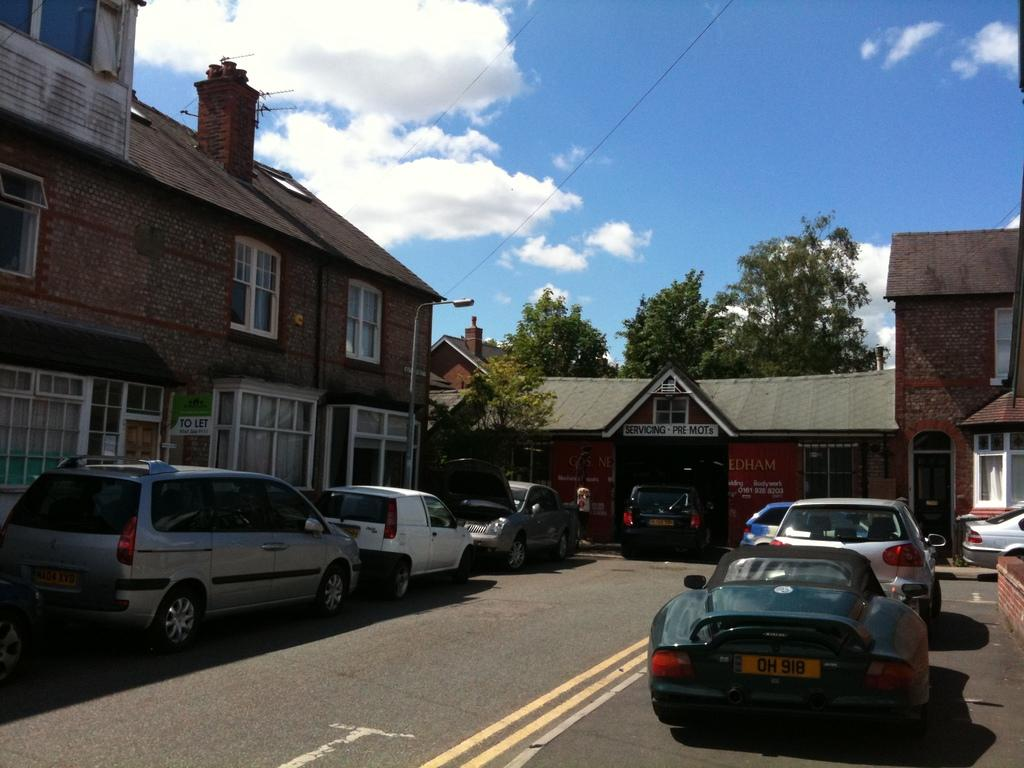What type of structures can be seen in the image? There are buildings in the image. What is happening on the road at the bottom of the image? There are cars on the road at the bottom of the image. What can be seen in the background of the image? There are trees and a pole visible in the background. What is visible at the top of the image? The sky is visible at the top of the image. What else is present in the image? Wires are present in the image. Can you see any cubs playing with icicles in the image? There are no cubs or icicles present in the image. What type of mist can be seen surrounding the buildings in the image? There is no mist visible in the image; the buildings, cars, trees, pole, sky, and wires are clearly visible. 